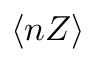<formula> <loc_0><loc_0><loc_500><loc_500>\langle n Z \rangle</formula> 